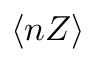<formula> <loc_0><loc_0><loc_500><loc_500>\langle n Z \rangle</formula> 